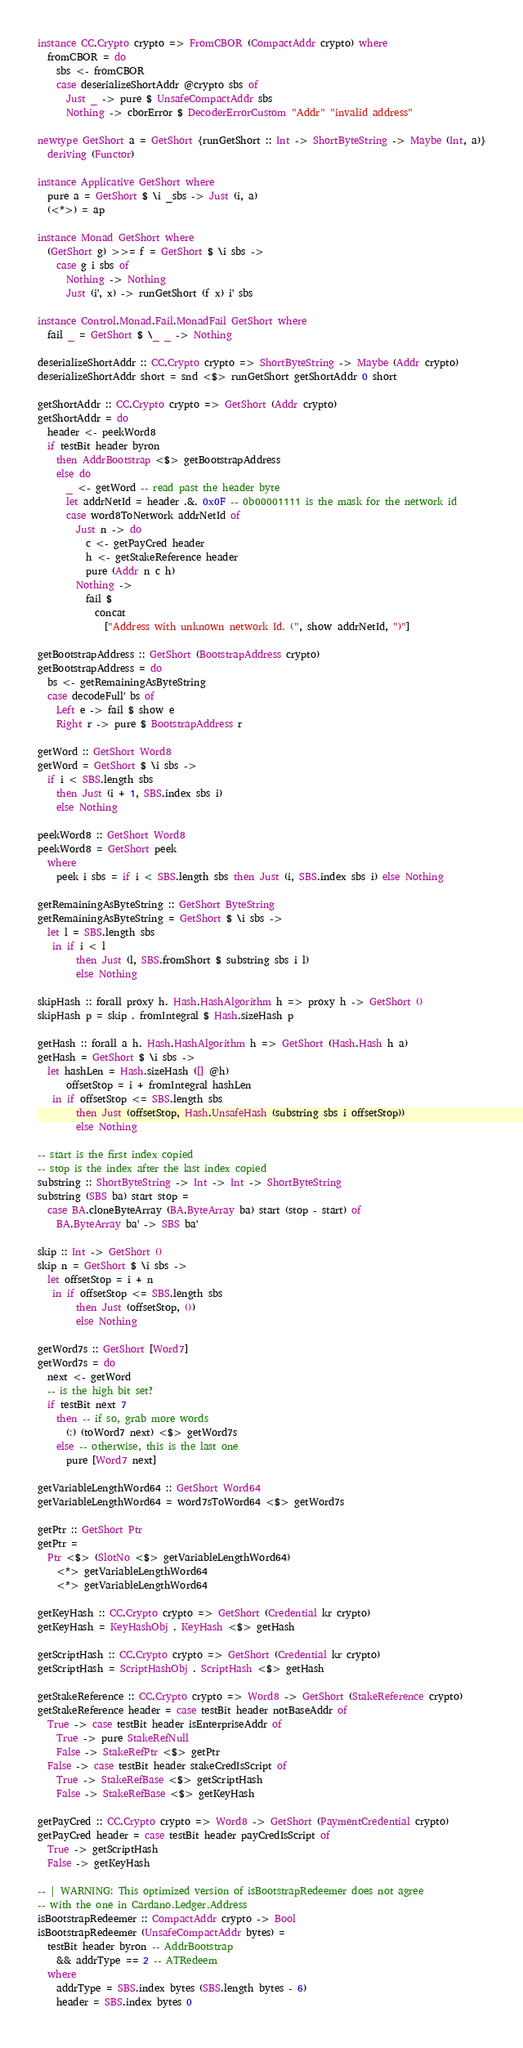<code> <loc_0><loc_0><loc_500><loc_500><_Haskell_>instance CC.Crypto crypto => FromCBOR (CompactAddr crypto) where
  fromCBOR = do
    sbs <- fromCBOR
    case deserializeShortAddr @crypto sbs of
      Just _ -> pure $ UnsafeCompactAddr sbs
      Nothing -> cborError $ DecoderErrorCustom "Addr" "invalid address"

newtype GetShort a = GetShort {runGetShort :: Int -> ShortByteString -> Maybe (Int, a)}
  deriving (Functor)

instance Applicative GetShort where
  pure a = GetShort $ \i _sbs -> Just (i, a)
  (<*>) = ap

instance Monad GetShort where
  (GetShort g) >>= f = GetShort $ \i sbs ->
    case g i sbs of
      Nothing -> Nothing
      Just (i', x) -> runGetShort (f x) i' sbs

instance Control.Monad.Fail.MonadFail GetShort where
  fail _ = GetShort $ \_ _ -> Nothing

deserializeShortAddr :: CC.Crypto crypto => ShortByteString -> Maybe (Addr crypto)
deserializeShortAddr short = snd <$> runGetShort getShortAddr 0 short

getShortAddr :: CC.Crypto crypto => GetShort (Addr crypto)
getShortAddr = do
  header <- peekWord8
  if testBit header byron
    then AddrBootstrap <$> getBootstrapAddress
    else do
      _ <- getWord -- read past the header byte
      let addrNetId = header .&. 0x0F -- 0b00001111 is the mask for the network id
      case word8ToNetwork addrNetId of
        Just n -> do
          c <- getPayCred header
          h <- getStakeReference header
          pure (Addr n c h)
        Nothing ->
          fail $
            concat
              ["Address with unknown network Id. (", show addrNetId, ")"]

getBootstrapAddress :: GetShort (BootstrapAddress crypto)
getBootstrapAddress = do
  bs <- getRemainingAsByteString
  case decodeFull' bs of
    Left e -> fail $ show e
    Right r -> pure $ BootstrapAddress r

getWord :: GetShort Word8
getWord = GetShort $ \i sbs ->
  if i < SBS.length sbs
    then Just (i + 1, SBS.index sbs i)
    else Nothing

peekWord8 :: GetShort Word8
peekWord8 = GetShort peek
  where
    peek i sbs = if i < SBS.length sbs then Just (i, SBS.index sbs i) else Nothing

getRemainingAsByteString :: GetShort ByteString
getRemainingAsByteString = GetShort $ \i sbs ->
  let l = SBS.length sbs
   in if i < l
        then Just (l, SBS.fromShort $ substring sbs i l)
        else Nothing

skipHash :: forall proxy h. Hash.HashAlgorithm h => proxy h -> GetShort ()
skipHash p = skip . fromIntegral $ Hash.sizeHash p

getHash :: forall a h. Hash.HashAlgorithm h => GetShort (Hash.Hash h a)
getHash = GetShort $ \i sbs ->
  let hashLen = Hash.sizeHash ([] @h)
      offsetStop = i + fromIntegral hashLen
   in if offsetStop <= SBS.length sbs
        then Just (offsetStop, Hash.UnsafeHash (substring sbs i offsetStop))
        else Nothing

-- start is the first index copied
-- stop is the index after the last index copied
substring :: ShortByteString -> Int -> Int -> ShortByteString
substring (SBS ba) start stop =
  case BA.cloneByteArray (BA.ByteArray ba) start (stop - start) of
    BA.ByteArray ba' -> SBS ba'

skip :: Int -> GetShort ()
skip n = GetShort $ \i sbs ->
  let offsetStop = i + n
   in if offsetStop <= SBS.length sbs
        then Just (offsetStop, ())
        else Nothing

getWord7s :: GetShort [Word7]
getWord7s = do
  next <- getWord
  -- is the high bit set?
  if testBit next 7
    then -- if so, grab more words
      (:) (toWord7 next) <$> getWord7s
    else -- otherwise, this is the last one
      pure [Word7 next]

getVariableLengthWord64 :: GetShort Word64
getVariableLengthWord64 = word7sToWord64 <$> getWord7s

getPtr :: GetShort Ptr
getPtr =
  Ptr <$> (SlotNo <$> getVariableLengthWord64)
    <*> getVariableLengthWord64
    <*> getVariableLengthWord64

getKeyHash :: CC.Crypto crypto => GetShort (Credential kr crypto)
getKeyHash = KeyHashObj . KeyHash <$> getHash

getScriptHash :: CC.Crypto crypto => GetShort (Credential kr crypto)
getScriptHash = ScriptHashObj . ScriptHash <$> getHash

getStakeReference :: CC.Crypto crypto => Word8 -> GetShort (StakeReference crypto)
getStakeReference header = case testBit header notBaseAddr of
  True -> case testBit header isEnterpriseAddr of
    True -> pure StakeRefNull
    False -> StakeRefPtr <$> getPtr
  False -> case testBit header stakeCredIsScript of
    True -> StakeRefBase <$> getScriptHash
    False -> StakeRefBase <$> getKeyHash

getPayCred :: CC.Crypto crypto => Word8 -> GetShort (PaymentCredential crypto)
getPayCred header = case testBit header payCredIsScript of
  True -> getScriptHash
  False -> getKeyHash

-- | WARNING: This optimized version of isBootstrapRedeemer does not agree
-- with the one in Cardano.Ledger.Address
isBootstrapRedeemer :: CompactAddr crypto -> Bool
isBootstrapRedeemer (UnsafeCompactAddr bytes) =
  testBit header byron -- AddrBootstrap
    && addrType == 2 -- ATRedeem
  where
    addrType = SBS.index bytes (SBS.length bytes - 6)
    header = SBS.index bytes 0
</code> 